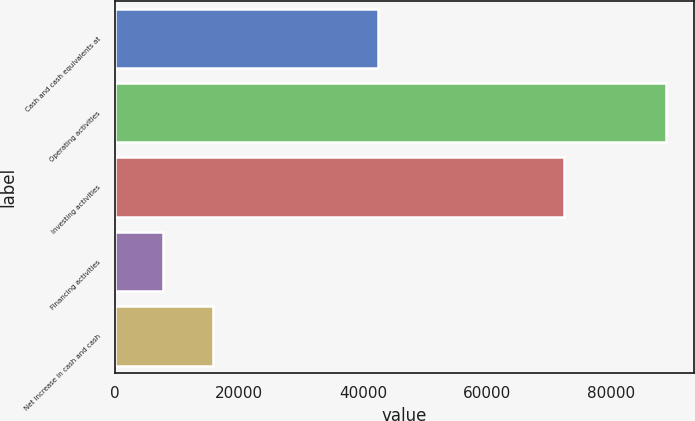Convert chart. <chart><loc_0><loc_0><loc_500><loc_500><bar_chart><fcel>Cash and cash equivalents at<fcel>Operating activities<fcel>Investing activities<fcel>Financing activities<fcel>Net increase in cash and cash<nl><fcel>42389<fcel>88933<fcel>72383<fcel>7650<fcel>15778.3<nl></chart> 